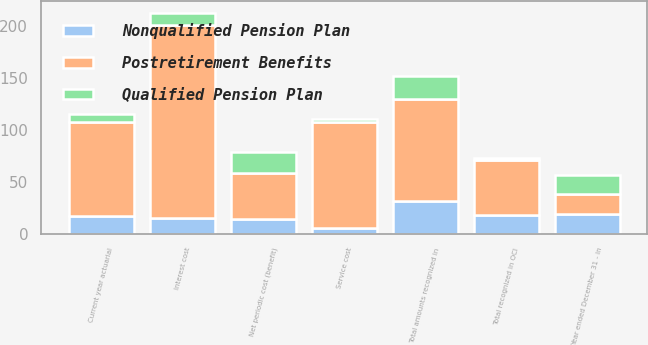Convert chart. <chart><loc_0><loc_0><loc_500><loc_500><stacked_bar_chart><ecel><fcel>Year ended December 31 - in<fcel>Service cost<fcel>Interest cost<fcel>Net periodic cost (benefit)<fcel>Current year actuarial<fcel>Total recognized in OCI<fcel>Total amounts recognized in<nl><fcel>Postretirement Benefits<fcel>19<fcel>102<fcel>186<fcel>45<fcel>91<fcel>53<fcel>98<nl><fcel>Qualified Pension Plan<fcel>19<fcel>3<fcel>12<fcel>20<fcel>7<fcel>2<fcel>22<nl><fcel>Nonqualified Pension Plan<fcel>19<fcel>6<fcel>15<fcel>14<fcel>17<fcel>18<fcel>32<nl></chart> 